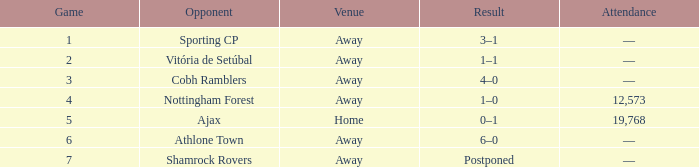What is the venue of game 3? Away. I'm looking to parse the entire table for insights. Could you assist me with that? {'header': ['Game', 'Opponent', 'Venue', 'Result', 'Attendance'], 'rows': [['1', 'Sporting CP', 'Away', '3–1', '—'], ['2', 'Vitória de Setúbal', 'Away', '1–1', '—'], ['3', 'Cobh Ramblers', 'Away', '4–0', '—'], ['4', 'Nottingham Forest', 'Away', '1–0', '12,573'], ['5', 'Ajax', 'Home', '0–1', '19,768'], ['6', 'Athlone Town', 'Away', '6–0', '—'], ['7', 'Shamrock Rovers', 'Away', 'Postponed', '—']]} 